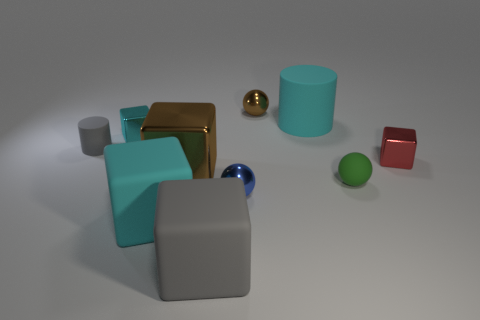Does the matte cylinder on the right side of the large brown block have the same color as the small cylinder?
Keep it short and to the point. No. What is the size of the gray rubber thing that is the same shape as the tiny cyan metal thing?
Provide a succinct answer. Large. Is there any other thing that is the same size as the cyan rubber cube?
Give a very brief answer. Yes. What material is the small sphere behind the big matte thing that is right of the small ball that is behind the tiny cyan block?
Offer a terse response. Metal. Is the number of tiny brown metallic spheres that are left of the brown metallic block greater than the number of red cubes that are right of the large cyan rubber block?
Give a very brief answer. No. Do the brown block and the green thing have the same size?
Ensure brevity in your answer.  No. What is the color of the large rubber object that is the same shape as the tiny gray matte thing?
Ensure brevity in your answer.  Cyan. How many other big matte cylinders have the same color as the large matte cylinder?
Offer a terse response. 0. Is the number of rubber balls that are on the right side of the tiny blue metallic object greater than the number of brown things?
Give a very brief answer. No. There is a matte thing to the right of the cyan matte thing behind the small red metallic object; what is its color?
Your answer should be compact. Green. 